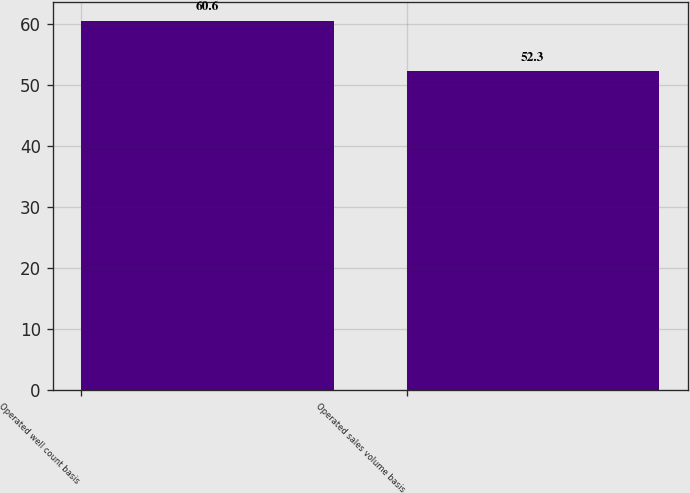<chart> <loc_0><loc_0><loc_500><loc_500><bar_chart><fcel>Operated well count basis<fcel>Operated sales volume basis<nl><fcel>60.6<fcel>52.3<nl></chart> 